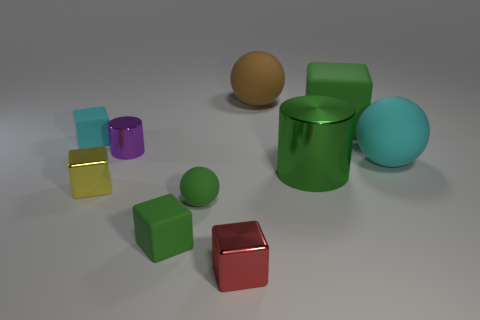Subtract all cyan matte spheres. How many spheres are left? 2 Subtract all yellow blocks. How many blocks are left? 4 Subtract all cylinders. How many objects are left? 8 Add 6 large green blocks. How many large green blocks are left? 7 Add 4 small red matte balls. How many small red matte balls exist? 4 Subtract 1 green cylinders. How many objects are left? 9 Subtract 1 cylinders. How many cylinders are left? 1 Subtract all green cylinders. Subtract all red spheres. How many cylinders are left? 1 Subtract all cyan cylinders. How many blue balls are left? 0 Subtract all tiny red shiny cubes. Subtract all brown balls. How many objects are left? 8 